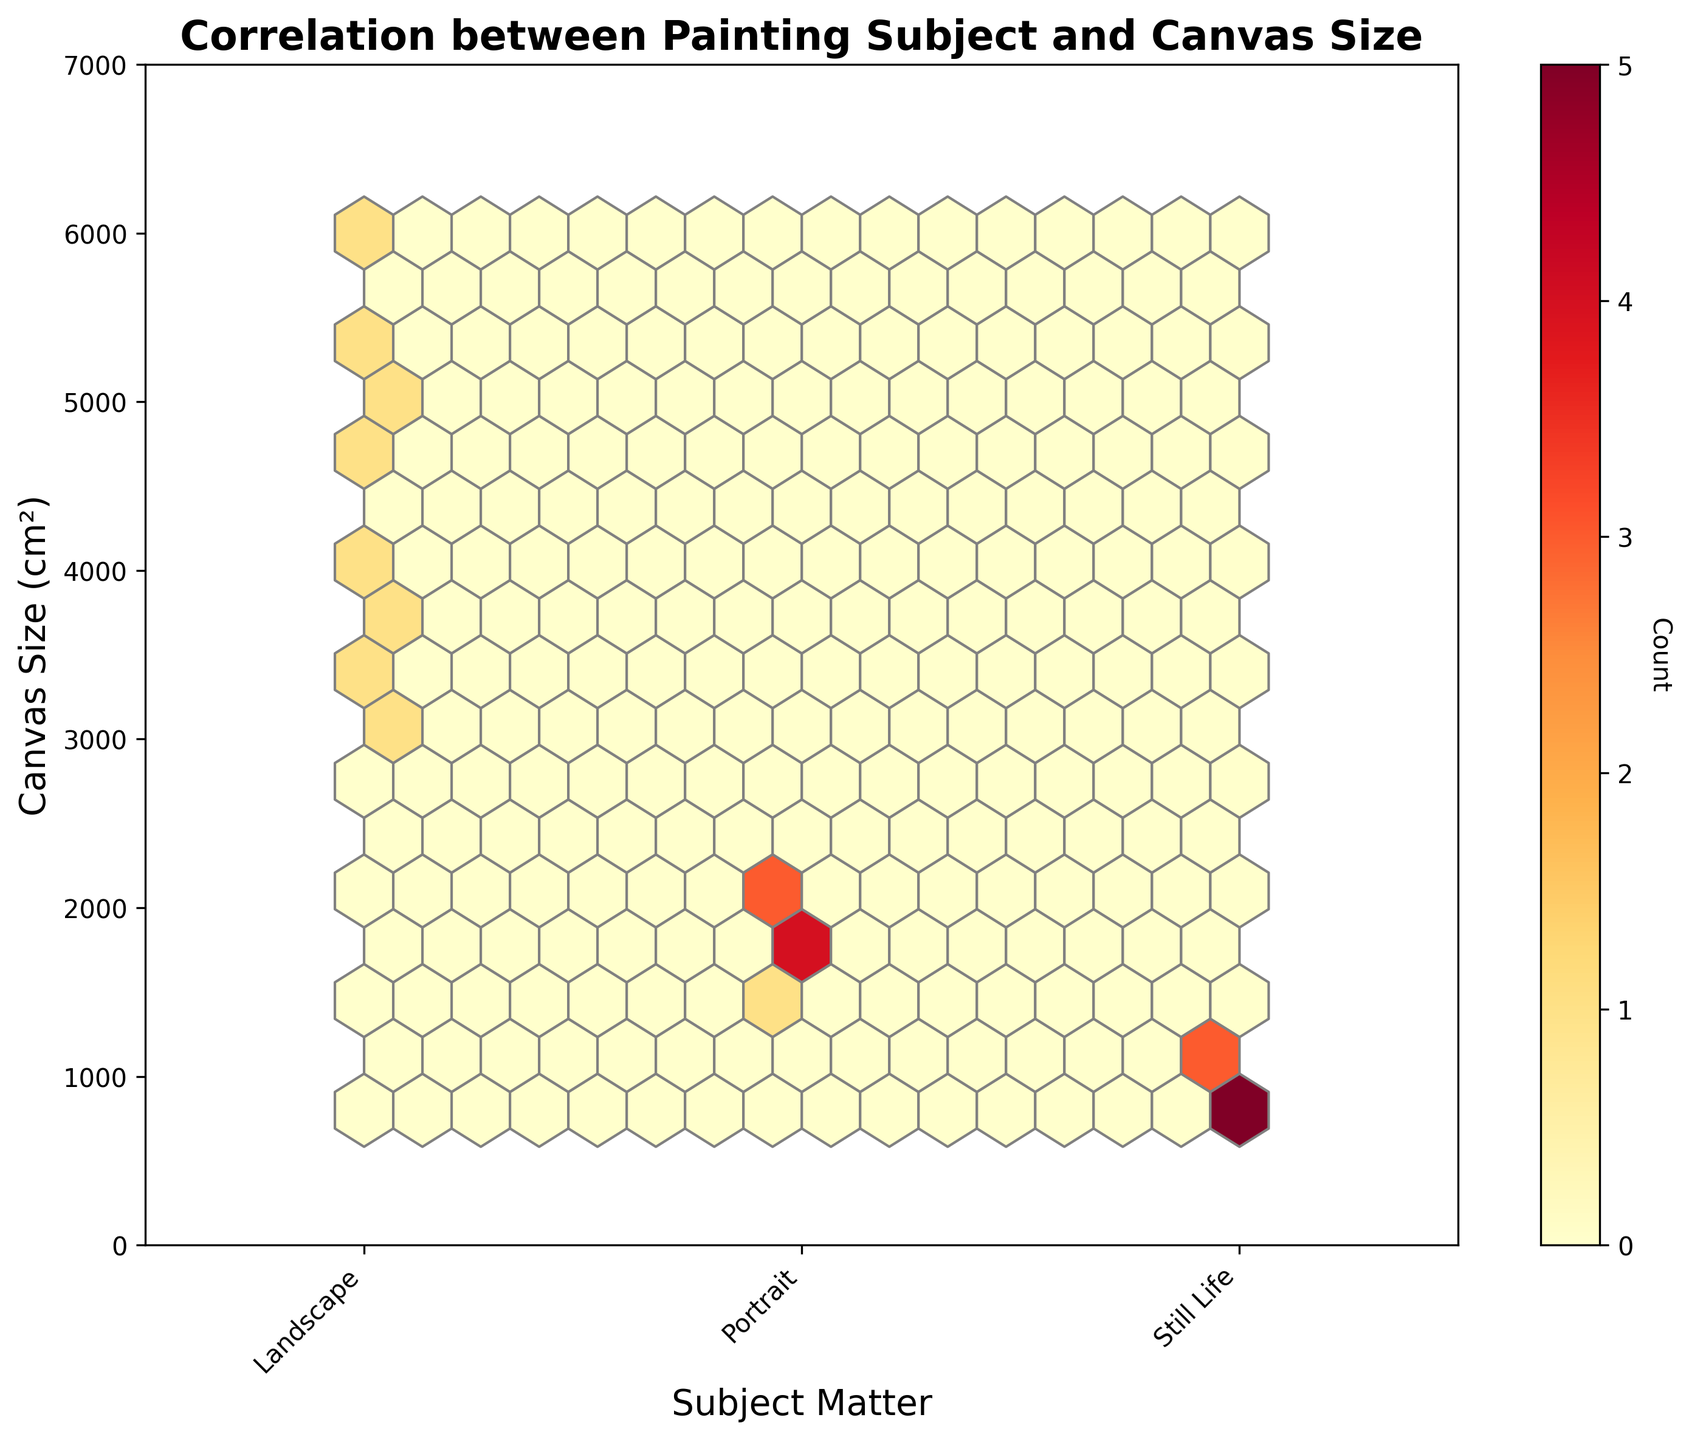What is the title of the plot? The title of the plot is displayed at the top in bold text.
Answer: "Correlation between Painting Subject and Canvas Size" What are the three categories of subject matter on the x-axis? The x-axis has three categories labeled for easy identification. They are shown as ticks along the x-axis
Answer: Landscape, Portrait, Still Life What is the y-axis range for canvas sizes? The range of the y-axis can be observed by looking at the minimum and maximum values shown alongside the axis.
Answer: 0 to 7000 cm² How can you identify which canvas size is most frequent for each subject? The hexbin plot uses color density to indicate frequency, with darker colors showing higher counts.
Answer: The most frequent canvas sizes can be found where the hexagons are darkest in color Which painting subject has the highest average canvas size? By observing the distribution of canvas sizes in the hexbin plot for each subject, you can compare where the highest concentrations of points appear. Landscapes consistently appear at higher values.
Answer: Landscape Which color represents higher frequency of data points in the hexbin plot? The color bar on the side of the plot shows a gradient, with lighter colors representing fewer points and darker ones representing more points.
Answer: Darker shades of red How many data points are used in the figure? The exact count of data points isn’t visible in a hexbin plot, but you can get an idea of the number by observing the density and distribution of hexagons. Each subject has 8 data points, making a total of
Answer: 24 What can you infer about the relationship between subject matter and canvas size? Comparing the density and spread of hexagons across the x-axis categories allows you to determine relationships. Landscapes use larger canvas sizes, while portraits and still lifes use smaller ones.
Answer: Landscapes have larger canvas sizes compared to portraits and still lifes Which category has the least variation in canvas sizes? The variation can be judged by the spread (range) of values within each hexagon cluster for the categories. Still Life appears more tightly clustered along the y-axis.
Answer: Still Life 